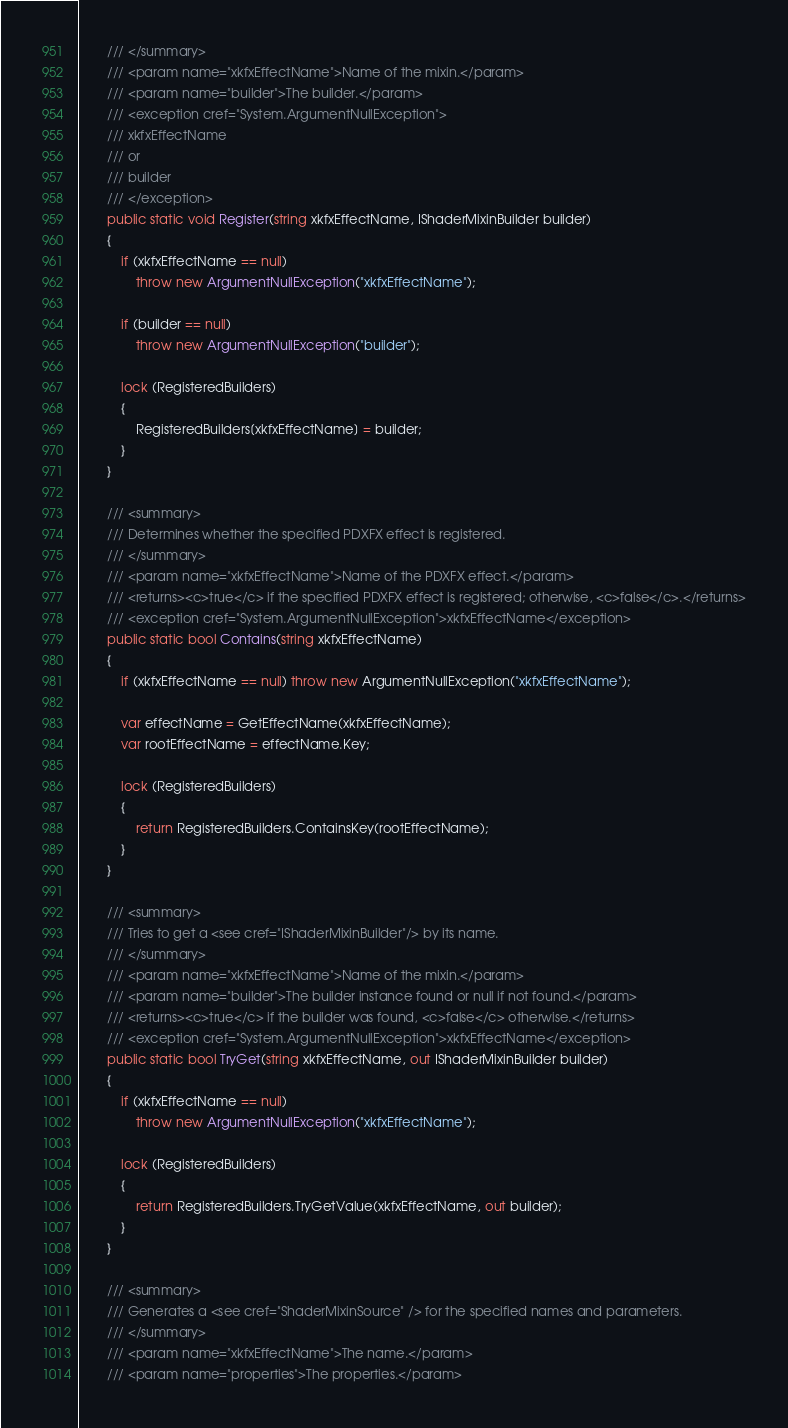Convert code to text. <code><loc_0><loc_0><loc_500><loc_500><_C#_>        /// </summary>
        /// <param name="xkfxEffectName">Name of the mixin.</param>
        /// <param name="builder">The builder.</param>
        /// <exception cref="System.ArgumentNullException">
        /// xkfxEffectName
        /// or
        /// builder
        /// </exception>
        public static void Register(string xkfxEffectName, IShaderMixinBuilder builder)
        {
            if (xkfxEffectName == null)
                throw new ArgumentNullException("xkfxEffectName");

            if (builder == null)
                throw new ArgumentNullException("builder");

            lock (RegisteredBuilders)
            {
                RegisteredBuilders[xkfxEffectName] = builder;
            }
        }

        /// <summary>
        /// Determines whether the specified PDXFX effect is registered.
        /// </summary>
        /// <param name="xkfxEffectName">Name of the PDXFX effect.</param>
        /// <returns><c>true</c> if the specified PDXFX effect is registered; otherwise, <c>false</c>.</returns>
        /// <exception cref="System.ArgumentNullException">xkfxEffectName</exception>
        public static bool Contains(string xkfxEffectName)
        {
            if (xkfxEffectName == null) throw new ArgumentNullException("xkfxEffectName");

            var effectName = GetEffectName(xkfxEffectName);
            var rootEffectName = effectName.Key;

            lock (RegisteredBuilders)
            {
                return RegisteredBuilders.ContainsKey(rootEffectName);
            }
        }

        /// <summary>
        /// Tries to get a <see cref="IShaderMixinBuilder"/> by its name.
        /// </summary>
        /// <param name="xkfxEffectName">Name of the mixin.</param>
        /// <param name="builder">The builder instance found or null if not found.</param>
        /// <returns><c>true</c> if the builder was found, <c>false</c> otherwise.</returns>
        /// <exception cref="System.ArgumentNullException">xkfxEffectName</exception>
        public static bool TryGet(string xkfxEffectName, out IShaderMixinBuilder builder)
        {
            if (xkfxEffectName == null)
                throw new ArgumentNullException("xkfxEffectName");

            lock (RegisteredBuilders)
            {
                return RegisteredBuilders.TryGetValue(xkfxEffectName, out builder);
            }
        }

        /// <summary>
        /// Generates a <see cref="ShaderMixinSource" /> for the specified names and parameters.
        /// </summary>
        /// <param name="xkfxEffectName">The name.</param>
        /// <param name="properties">The properties.</param></code> 